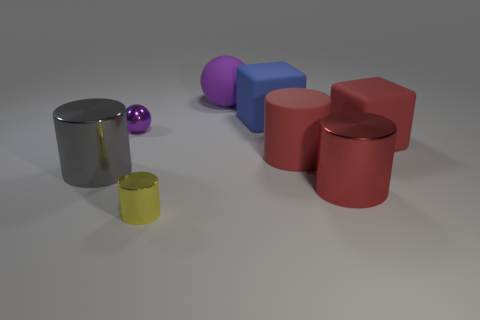How many red things have the same material as the small yellow object?
Offer a terse response. 1. What is the red object right of the red metal cylinder made of?
Ensure brevity in your answer.  Rubber. What is the shape of the shiny thing that is to the right of the big red matte object that is to the left of the block in front of the tiny purple shiny sphere?
Offer a terse response. Cylinder. There is a ball to the left of the purple rubber thing; is it the same color as the object behind the blue matte block?
Offer a terse response. Yes. Are there fewer red things that are left of the small purple metal ball than tiny metal objects in front of the red rubber cylinder?
Provide a short and direct response. Yes. What color is the small object that is the same shape as the big purple object?
Provide a succinct answer. Purple. Do the tiny yellow metallic thing and the big object left of the yellow shiny cylinder have the same shape?
Give a very brief answer. Yes. What number of objects are either large rubber objects in front of the tiny purple shiny sphere or things to the right of the tiny yellow cylinder?
Provide a short and direct response. 5. What material is the gray thing?
Your answer should be very brief. Metal. How many other things are the same size as the rubber cylinder?
Your answer should be compact. 5. 